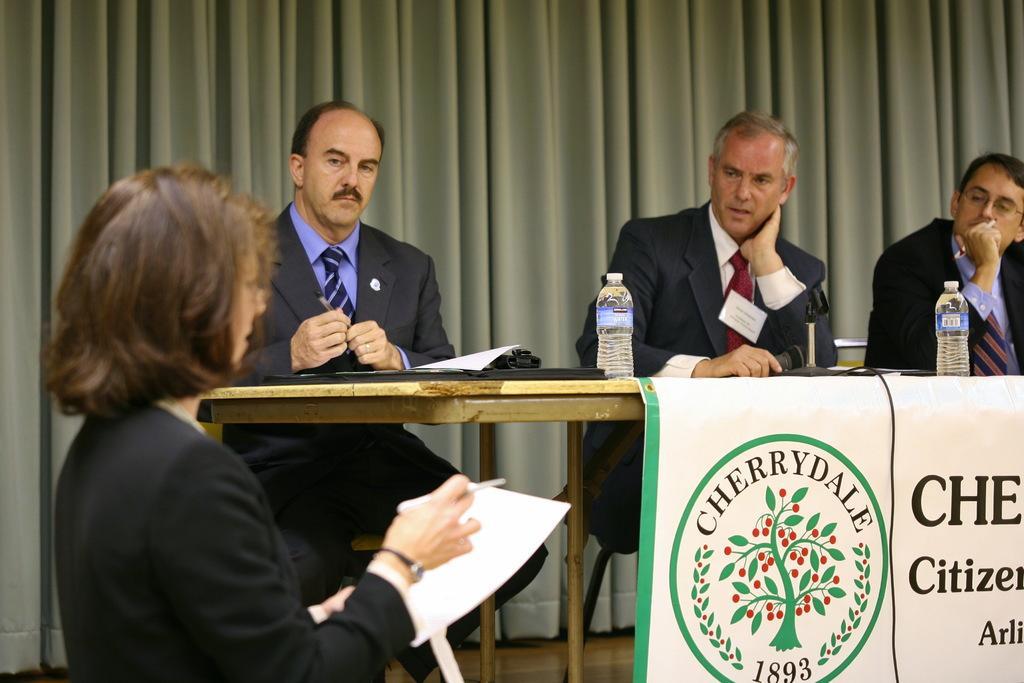Describe this image in one or two sentences. A lady in the left is wearing a watch holding a pen and a paper. There are three persons sitting on chairs. In front of them there is a table. On the table there is a banner, bottles, papers. Middle person is holding a mic. And the person in the right is wearing a specs. In the background there is a wall. 